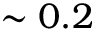<formula> <loc_0><loc_0><loc_500><loc_500>\sim 0 . 2</formula> 